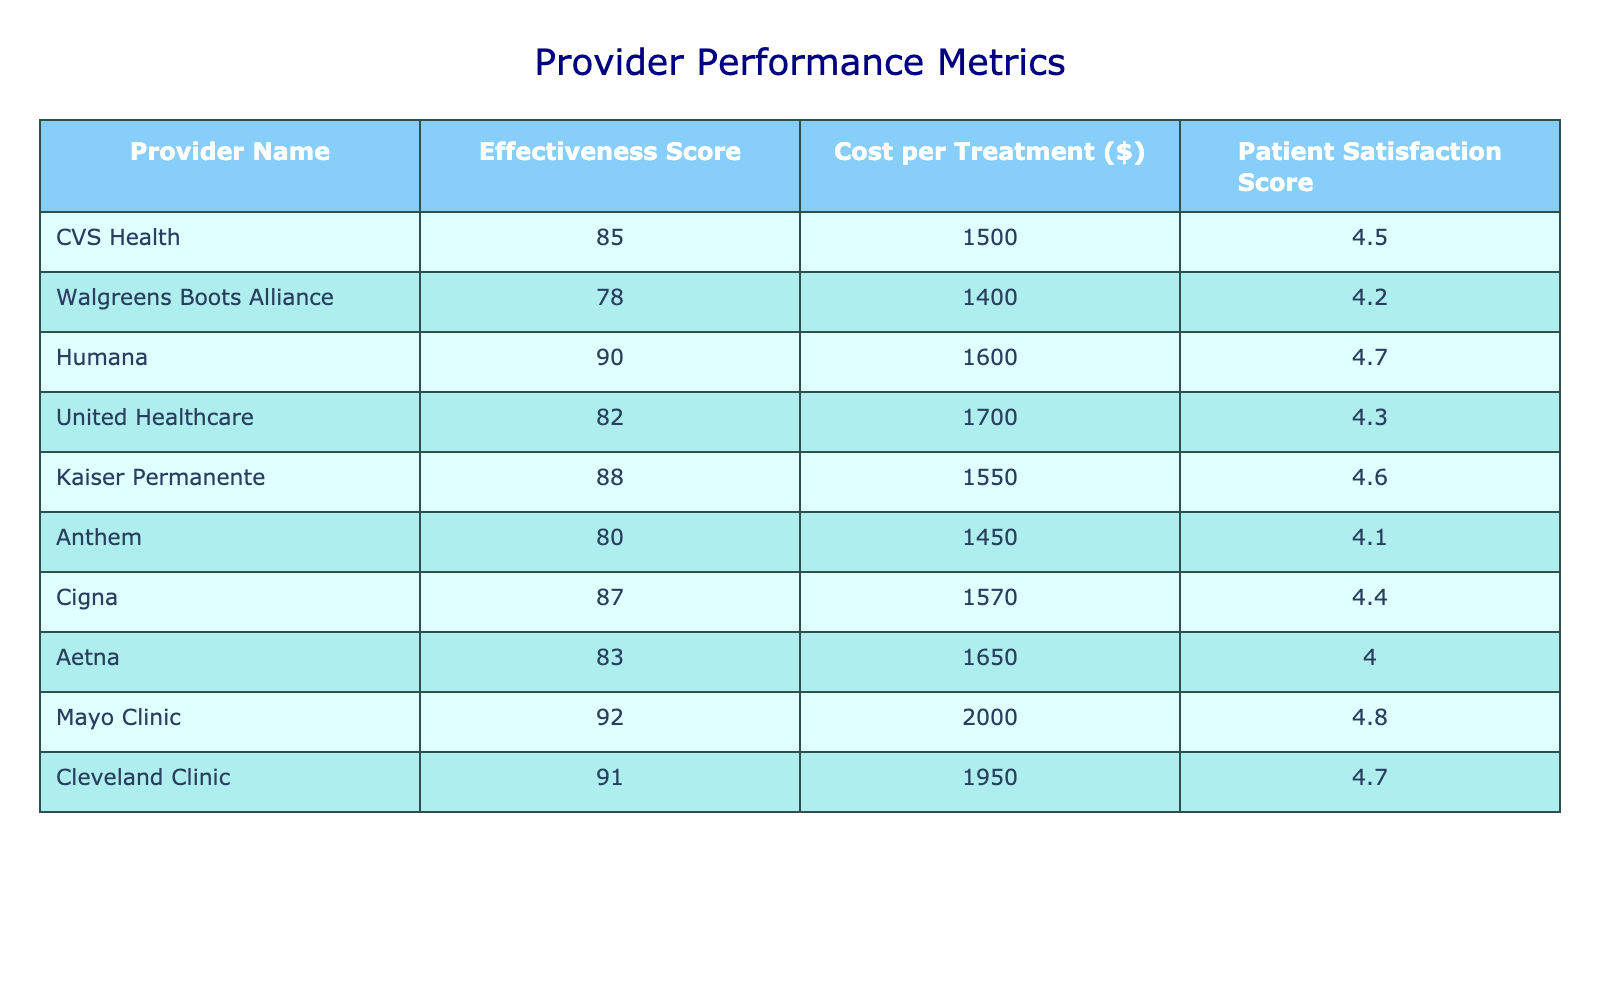What is the effectiveness score of CVS Health? The effectiveness score of CVS Health is directly listed in the table under the "Effectiveness Score" column, which shows a value of 85.
Answer: 85 Which provider has the highest patient satisfaction score? By examining the "Patient Satisfaction Score" column, Mayo Clinic has the highest score of 4.8, which is greater than all other providers listed.
Answer: Mayo Clinic What is the average cost per treatment across all providers? To find the average cost per treatment, sum all the costs: (1500 + 1400 + 1600 + 1700 + 1550 + 1450 + 1570 + 1650 + 2000 + 1950) = 16270. Then divide by the number of providers (10): 16270 / 10 = 1627.
Answer: 1627 Is Anthem more cost-effective than United Healthcare? Anthem has a cost of $1450 per treatment, while United Healthcare's cost is $1700, making Anthem more cost-effective since its cost is lower.
Answer: Yes Which provider has the lowest effectiveness score, and what is that score? Looking through the "Effectiveness Score" column, the lowest score is found with Walgreens Boots Alliance at 78.
Answer: Walgreens Boots Alliance, 78 If we consider only providers with effectiveness scores above 85, what is the average patient satisfaction score? The providers with effectiveness scores above 85 are Humana (90), Kaiser Permanente (88), Cigna (87), Mayo Clinic (92), and Cleveland Clinic (91). Their satisfaction scores are 4.7, 4.6, 4.4, 4.8, and 4.7 respectively. The average is (4.7 + 4.6 + 4.4 + 4.8 + 4.7) / 5 = 4.64.
Answer: 4.64 Are there any providers with a patient satisfaction score below 4.2? Yes, looking through the "Patient Satisfaction Score" column, Anthem has a score of 4.1, which is below 4.2.
Answer: Yes What is the cost difference between the most and least cost-effective providers? The most cost-effective provider is Anthem, with a cost of $1450, and the least cost-effective is Mayo Clinic, which costs $2000. The difference is $2000 - $1450 = $550.
Answer: 550 Which provider has an effectiveness score greater than 85 and a patient satisfaction score of 4.7? The table indicates that Mayo Clinic and Cleveland Clinic both meet these criteria, with effectiveness scores of 92 and 91, respectively, and both have a patient satisfaction score of 4.7.
Answer: Mayo Clinic, Cleveland Clinic 